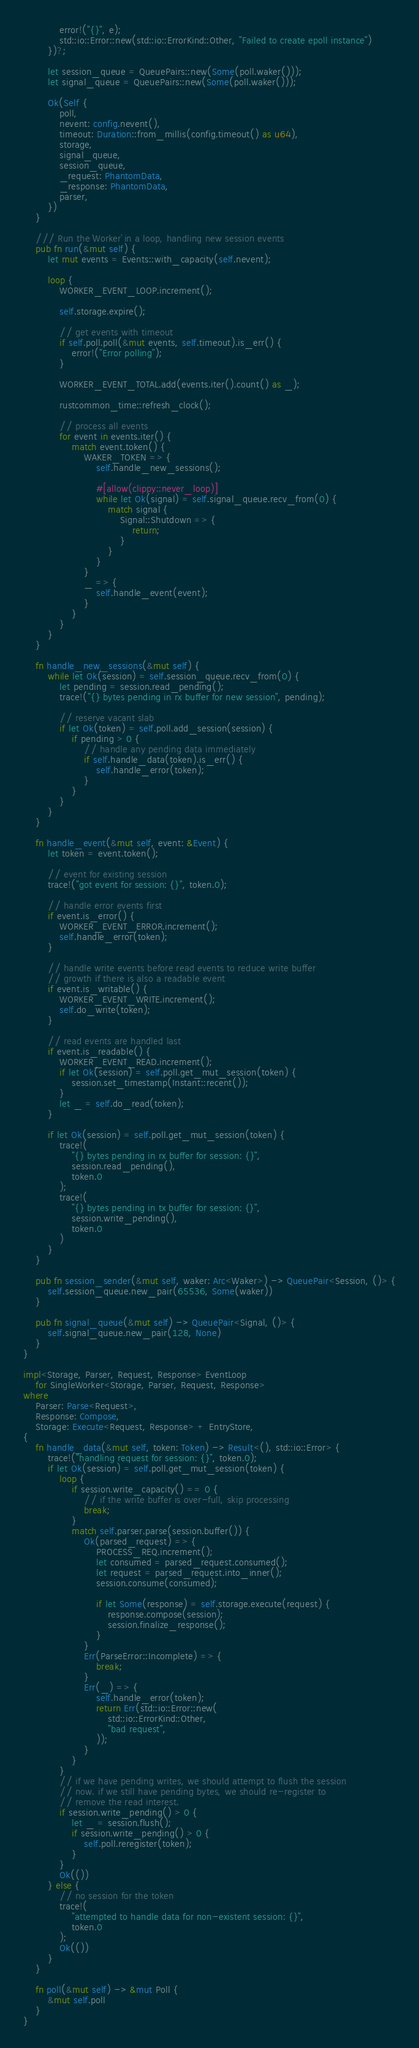<code> <loc_0><loc_0><loc_500><loc_500><_Rust_>            error!("{}", e);
            std::io::Error::new(std::io::ErrorKind::Other, "Failed to create epoll instance")
        })?;

        let session_queue = QueuePairs::new(Some(poll.waker()));
        let signal_queue = QueuePairs::new(Some(poll.waker()));

        Ok(Self {
            poll,
            nevent: config.nevent(),
            timeout: Duration::from_millis(config.timeout() as u64),
            storage,
            signal_queue,
            session_queue,
            _request: PhantomData,
            _response: PhantomData,
            parser,
        })
    }

    /// Run the `Worker` in a loop, handling new session events
    pub fn run(&mut self) {
        let mut events = Events::with_capacity(self.nevent);

        loop {
            WORKER_EVENT_LOOP.increment();

            self.storage.expire();

            // get events with timeout
            if self.poll.poll(&mut events, self.timeout).is_err() {
                error!("Error polling");
            }

            WORKER_EVENT_TOTAL.add(events.iter().count() as _);

            rustcommon_time::refresh_clock();

            // process all events
            for event in events.iter() {
                match event.token() {
                    WAKER_TOKEN => {
                        self.handle_new_sessions();

                        #[allow(clippy::never_loop)]
                        while let Ok(signal) = self.signal_queue.recv_from(0) {
                            match signal {
                                Signal::Shutdown => {
                                    return;
                                }
                            }
                        }
                    }
                    _ => {
                        self.handle_event(event);
                    }
                }
            }
        }
    }

    fn handle_new_sessions(&mut self) {
        while let Ok(session) = self.session_queue.recv_from(0) {
            let pending = session.read_pending();
            trace!("{} bytes pending in rx buffer for new session", pending);

            // reserve vacant slab
            if let Ok(token) = self.poll.add_session(session) {
                if pending > 0 {
                    // handle any pending data immediately
                    if self.handle_data(token).is_err() {
                        self.handle_error(token);
                    }
                }
            }
        }
    }

    fn handle_event(&mut self, event: &Event) {
        let token = event.token();

        // event for existing session
        trace!("got event for session: {}", token.0);

        // handle error events first
        if event.is_error() {
            WORKER_EVENT_ERROR.increment();
            self.handle_error(token);
        }

        // handle write events before read events to reduce write buffer
        // growth if there is also a readable event
        if event.is_writable() {
            WORKER_EVENT_WRITE.increment();
            self.do_write(token);
        }

        // read events are handled last
        if event.is_readable() {
            WORKER_EVENT_READ.increment();
            if let Ok(session) = self.poll.get_mut_session(token) {
                session.set_timestamp(Instant::recent());
            }
            let _ = self.do_read(token);
        }

        if let Ok(session) = self.poll.get_mut_session(token) {
            trace!(
                "{} bytes pending in rx buffer for session: {}",
                session.read_pending(),
                token.0
            );
            trace!(
                "{} bytes pending in tx buffer for session: {}",
                session.write_pending(),
                token.0
            )
        }
    }

    pub fn session_sender(&mut self, waker: Arc<Waker>) -> QueuePair<Session, ()> {
        self.session_queue.new_pair(65536, Some(waker))
    }

    pub fn signal_queue(&mut self) -> QueuePair<Signal, ()> {
        self.signal_queue.new_pair(128, None)
    }
}

impl<Storage, Parser, Request, Response> EventLoop
    for SingleWorker<Storage, Parser, Request, Response>
where
    Parser: Parse<Request>,
    Response: Compose,
    Storage: Execute<Request, Response> + EntryStore,
{
    fn handle_data(&mut self, token: Token) -> Result<(), std::io::Error> {
        trace!("handling request for session: {}", token.0);
        if let Ok(session) = self.poll.get_mut_session(token) {
            loop {
                if session.write_capacity() == 0 {
                    // if the write buffer is over-full, skip processing
                    break;
                }
                match self.parser.parse(session.buffer()) {
                    Ok(parsed_request) => {
                        PROCESS_REQ.increment();
                        let consumed = parsed_request.consumed();
                        let request = parsed_request.into_inner();
                        session.consume(consumed);

                        if let Some(response) = self.storage.execute(request) {
                            response.compose(session);
                            session.finalize_response();
                        }
                    }
                    Err(ParseError::Incomplete) => {
                        break;
                    }
                    Err(_) => {
                        self.handle_error(token);
                        return Err(std::io::Error::new(
                            std::io::ErrorKind::Other,
                            "bad request",
                        ));
                    }
                }
            }
            // if we have pending writes, we should attempt to flush the session
            // now. if we still have pending bytes, we should re-register to
            // remove the read interest.
            if session.write_pending() > 0 {
                let _ = session.flush();
                if session.write_pending() > 0 {
                    self.poll.reregister(token);
                }
            }
            Ok(())
        } else {
            // no session for the token
            trace!(
                "attempted to handle data for non-existent session: {}",
                token.0
            );
            Ok(())
        }
    }

    fn poll(&mut self) -> &mut Poll {
        &mut self.poll
    }
}
</code> 